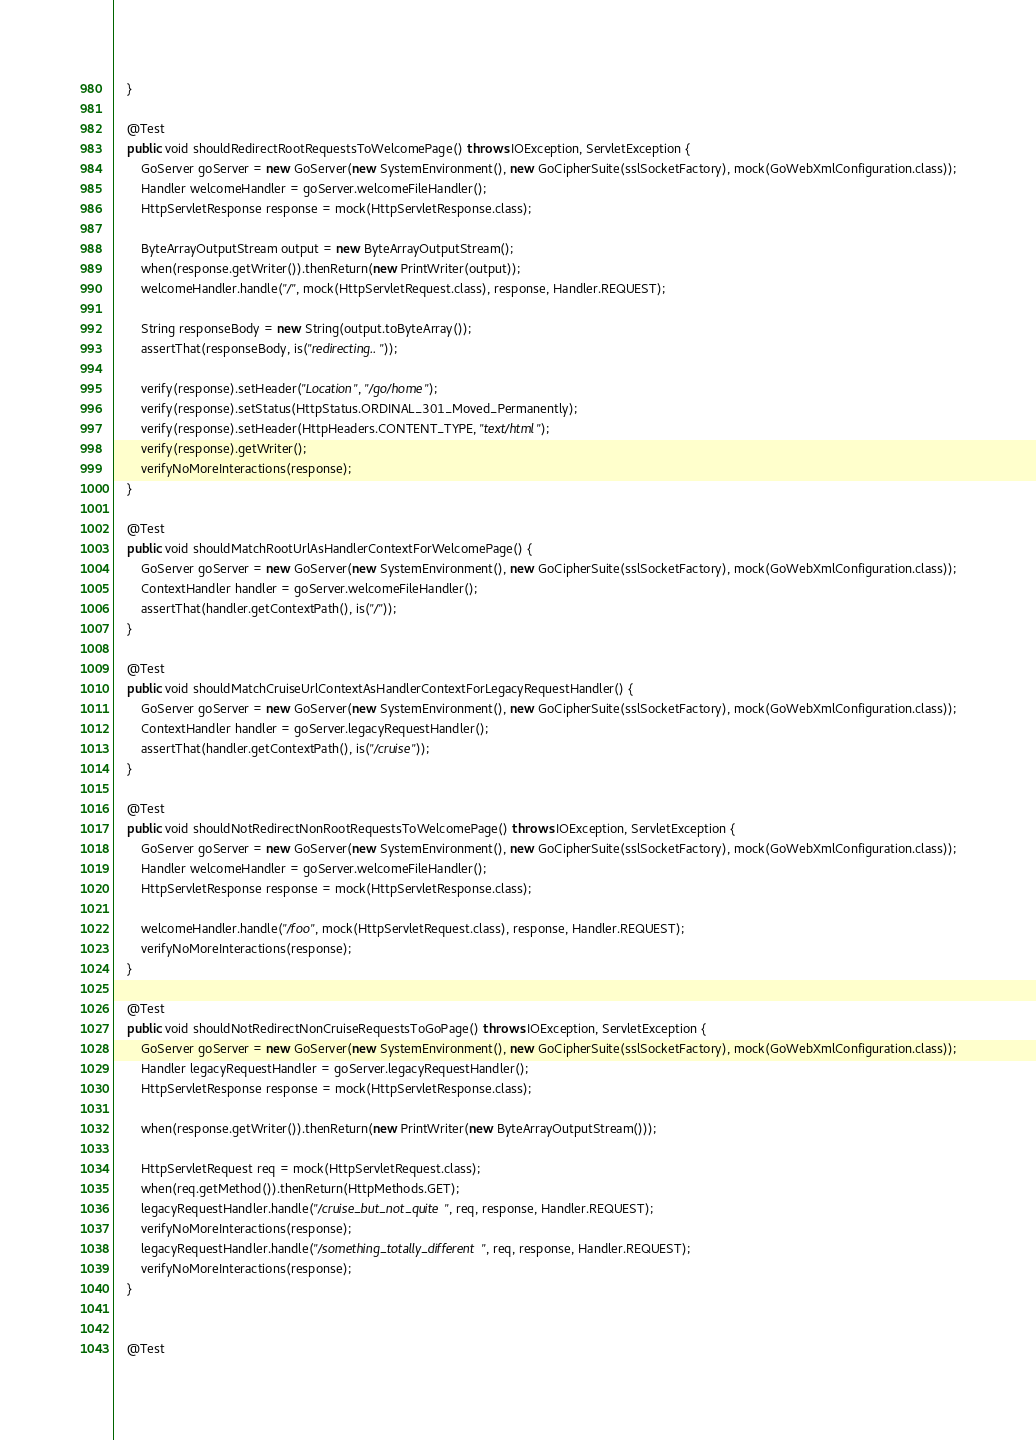Convert code to text. <code><loc_0><loc_0><loc_500><loc_500><_Java_>    }

    @Test
    public void shouldRedirectRootRequestsToWelcomePage() throws IOException, ServletException {
        GoServer goServer = new GoServer(new SystemEnvironment(), new GoCipherSuite(sslSocketFactory), mock(GoWebXmlConfiguration.class));
        Handler welcomeHandler = goServer.welcomeFileHandler();
        HttpServletResponse response = mock(HttpServletResponse.class);

        ByteArrayOutputStream output = new ByteArrayOutputStream();
        when(response.getWriter()).thenReturn(new PrintWriter(output));
        welcomeHandler.handle("/", mock(HttpServletRequest.class), response, Handler.REQUEST);

        String responseBody = new String(output.toByteArray());
        assertThat(responseBody, is("redirecting.."));

        verify(response).setHeader("Location", "/go/home");
        verify(response).setStatus(HttpStatus.ORDINAL_301_Moved_Permanently);
        verify(response).setHeader(HttpHeaders.CONTENT_TYPE, "text/html");
        verify(response).getWriter();
        verifyNoMoreInteractions(response);
    }

    @Test
    public void shouldMatchRootUrlAsHandlerContextForWelcomePage() {
        GoServer goServer = new GoServer(new SystemEnvironment(), new GoCipherSuite(sslSocketFactory), mock(GoWebXmlConfiguration.class));
        ContextHandler handler = goServer.welcomeFileHandler();
        assertThat(handler.getContextPath(), is("/"));
    }
    
    @Test
    public void shouldMatchCruiseUrlContextAsHandlerContextForLegacyRequestHandler() {
        GoServer goServer = new GoServer(new SystemEnvironment(), new GoCipherSuite(sslSocketFactory), mock(GoWebXmlConfiguration.class));
        ContextHandler handler = goServer.legacyRequestHandler();
        assertThat(handler.getContextPath(), is("/cruise"));
    }

    @Test
    public void shouldNotRedirectNonRootRequestsToWelcomePage() throws IOException, ServletException {
        GoServer goServer = new GoServer(new SystemEnvironment(), new GoCipherSuite(sslSocketFactory), mock(GoWebXmlConfiguration.class));
        Handler welcomeHandler = goServer.welcomeFileHandler();
        HttpServletResponse response = mock(HttpServletResponse.class);

        welcomeHandler.handle("/foo", mock(HttpServletRequest.class), response, Handler.REQUEST);
        verifyNoMoreInteractions(response);
    }

    @Test
    public void shouldNotRedirectNonCruiseRequestsToGoPage() throws IOException, ServletException {
        GoServer goServer = new GoServer(new SystemEnvironment(), new GoCipherSuite(sslSocketFactory), mock(GoWebXmlConfiguration.class));
        Handler legacyRequestHandler = goServer.legacyRequestHandler();
        HttpServletResponse response = mock(HttpServletResponse.class);

        when(response.getWriter()).thenReturn(new PrintWriter(new ByteArrayOutputStream()));

        HttpServletRequest req = mock(HttpServletRequest.class);
        when(req.getMethod()).thenReturn(HttpMethods.GET);
        legacyRequestHandler.handle("/cruise_but_not_quite", req, response, Handler.REQUEST);
        verifyNoMoreInteractions(response);
        legacyRequestHandler.handle("/something_totally_different", req, response, Handler.REQUEST);
        verifyNoMoreInteractions(response);
    }


    @Test</code> 